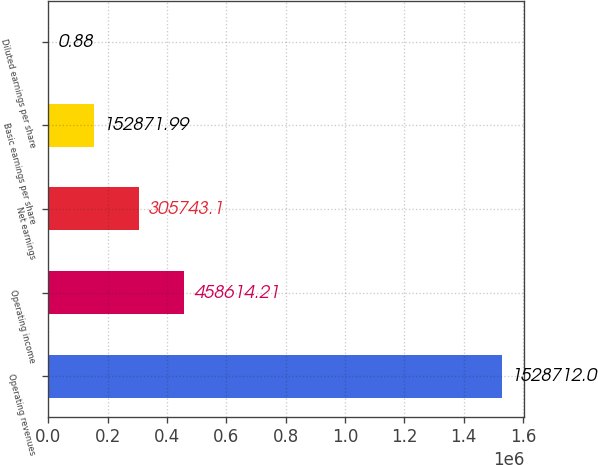Convert chart. <chart><loc_0><loc_0><loc_500><loc_500><bar_chart><fcel>Operating revenues<fcel>Operating income<fcel>Net earnings<fcel>Basic earnings per share<fcel>Diluted earnings per share<nl><fcel>1.52871e+06<fcel>458614<fcel>305743<fcel>152872<fcel>0.88<nl></chart> 